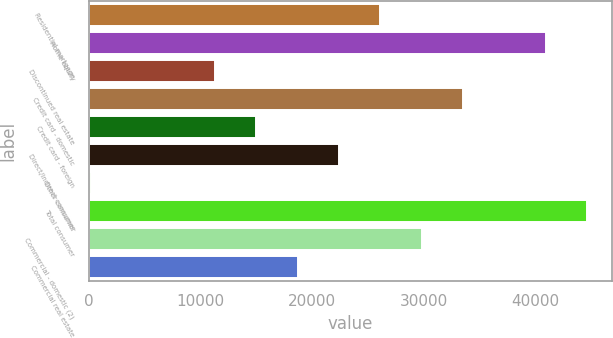Convert chart to OTSL. <chart><loc_0><loc_0><loc_500><loc_500><bar_chart><fcel>Residential mortgage<fcel>Home equity<fcel>Discontinued real estate<fcel>Credit card - domestic<fcel>Credit card - foreign<fcel>Direct/Indirect consumer<fcel>Other consumer<fcel>Total consumer<fcel>Commercial - domestic (2)<fcel>Commercial real estate<nl><fcel>26101.2<fcel>40899.6<fcel>11302.8<fcel>33500.4<fcel>15002.4<fcel>22401.6<fcel>204<fcel>44599.2<fcel>29800.8<fcel>18702<nl></chart> 